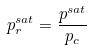<formula> <loc_0><loc_0><loc_500><loc_500>p _ { r } ^ { s a t } = \frac { p ^ { s a t } } { p _ { c } }</formula> 